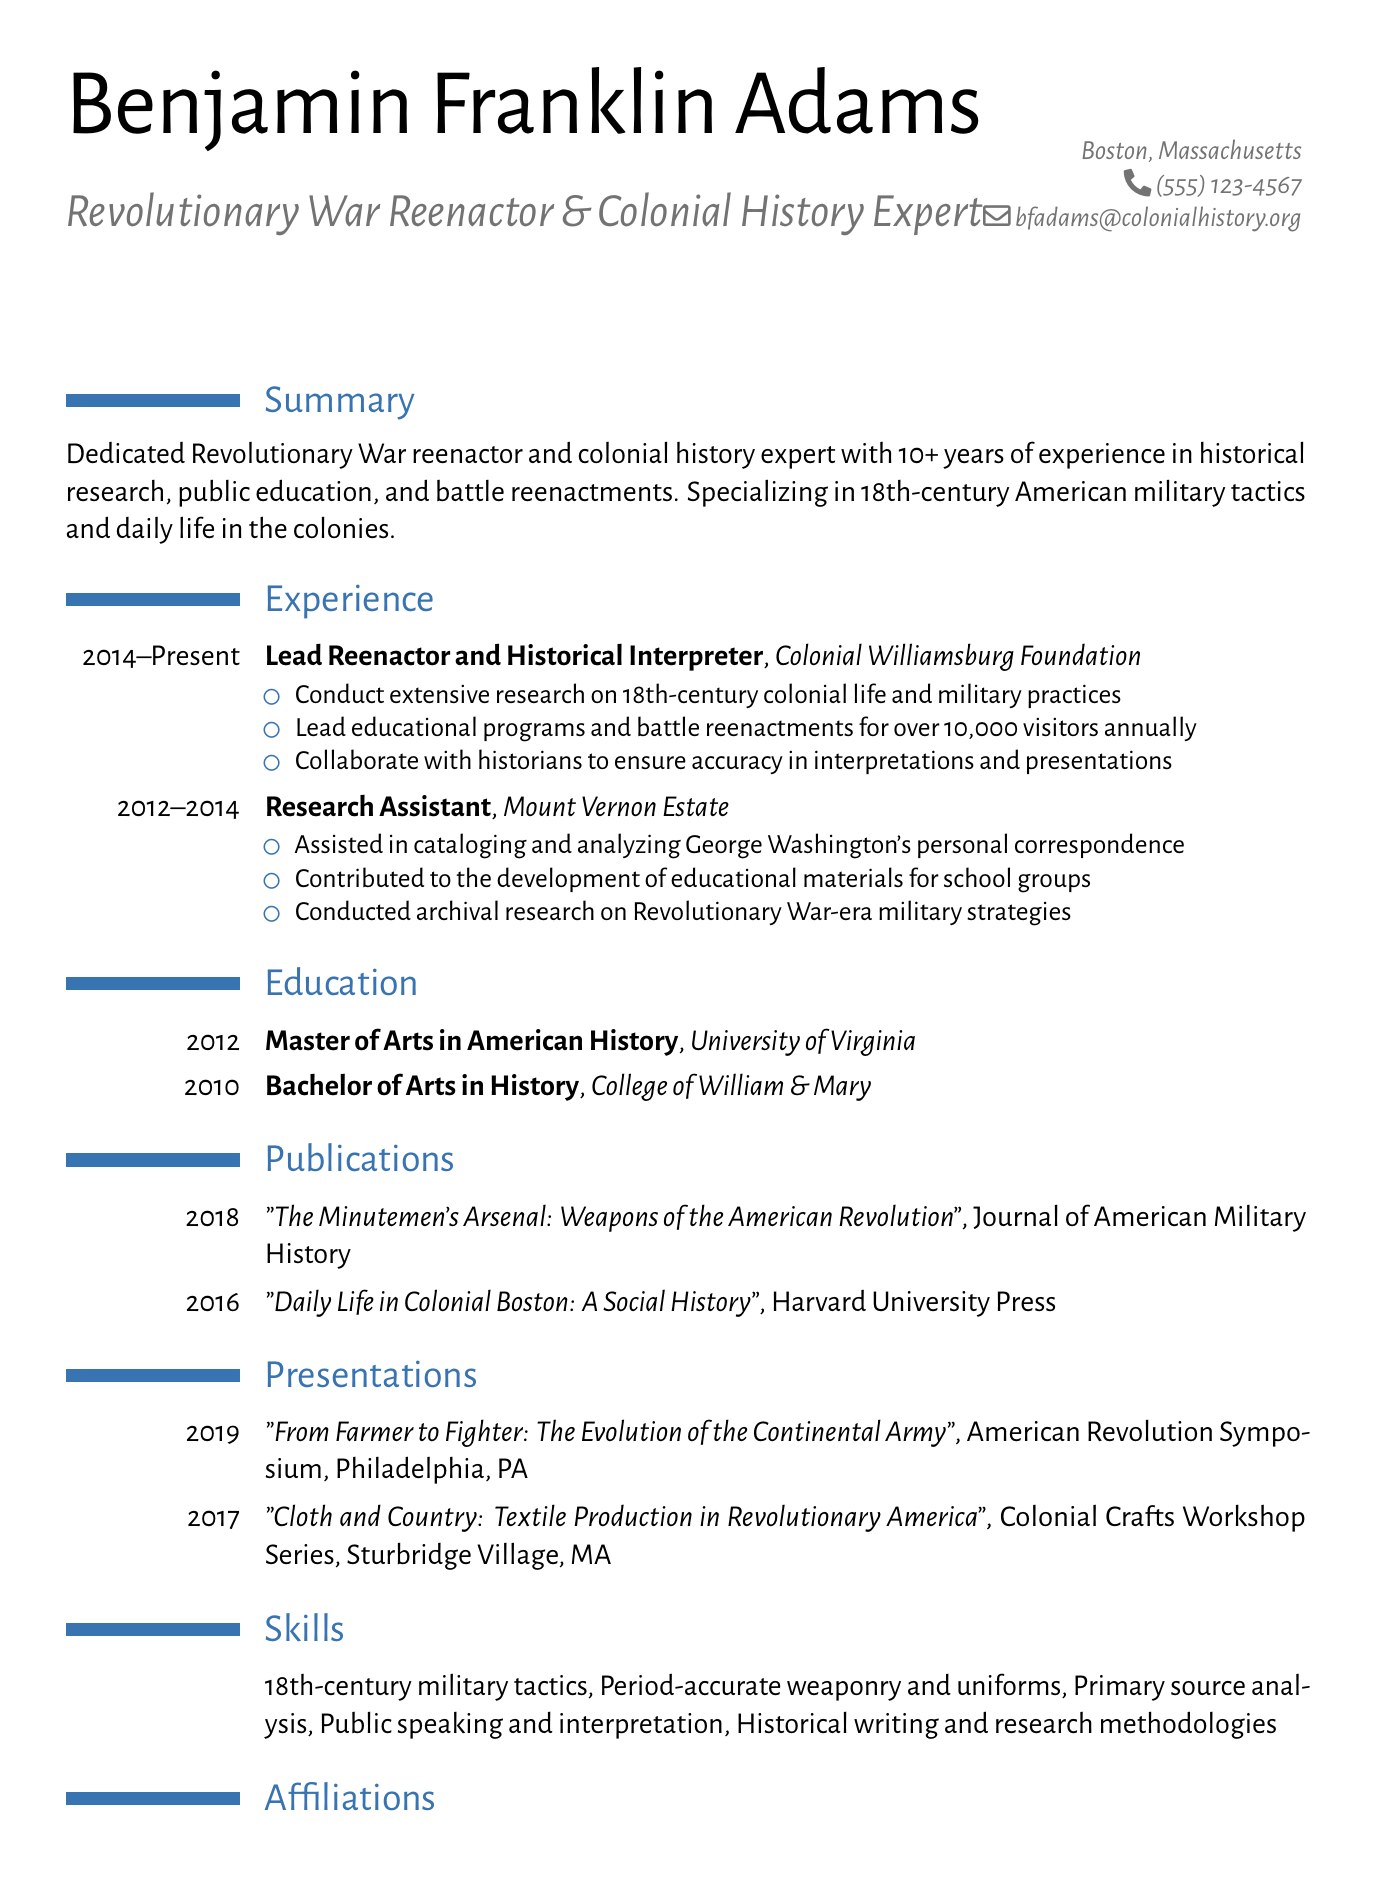What is Benjamin Franklin Adams' email address? The email address of Benjamin Franklin Adams is listed in the personal information section of the document.
Answer: bfadams@colonialhistory.org What degree did Benjamin obtain in 2012? The document states that he earned a Master of Arts in American History in 2012.
Answer: Master of Arts in American History How many years of experience does Benjamin have in historical research? The summary indicates he has over 10 years of experience in historical research.
Answer: 10+ What is the title of Benjamin's publication from 2016? The title of his publication from 2016 is provided in the publications section of the document.
Answer: Daily Life in Colonial Boston: A Social History In which year did Benjamin present at the American Revolution Symposium? The document specifies that he presented there in 2019.
Answer: 2019 Which organization has Benjamin been associated with since 2014? His job title and organization provide this information in the experience section of the document.
Answer: Colonial Williamsburg Foundation What skill involves historical writing and research methodologies? This specific skill is mentioned in the skills section of the document, indicating Benjamin's expertise.
Answer: Historical writing and research methodologies How many educational institutions did Benjamin attend? The education section lists two degrees from different institutions, showing the number of institutions attended.
Answer: 2 What is the location of the Colonial Crafts Workshop Series? This information is provided in the presentations section, indicating where the event took place.
Answer: Sturbridge Village, MA 